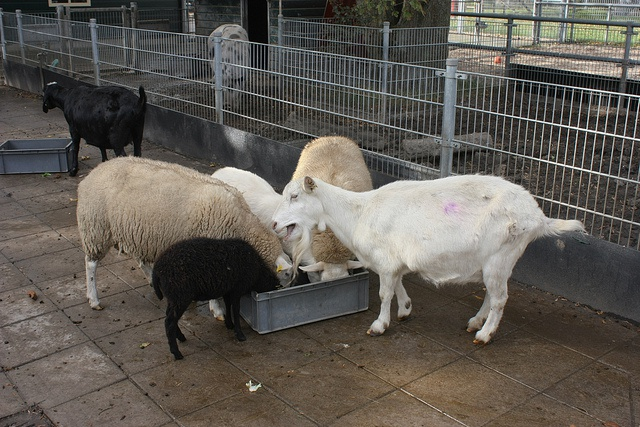Describe the objects in this image and their specific colors. I can see sheep in black, darkgray, and gray tones, sheep in black and gray tones, sheep in black, darkgray, gray, and tan tones, and sheep in black, lightgray, darkgray, and gray tones in this image. 